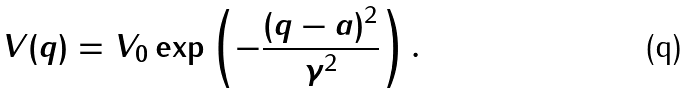Convert formula to latex. <formula><loc_0><loc_0><loc_500><loc_500>V ( q ) = V _ { 0 } \exp \left ( - \frac { ( q - a ) ^ { 2 } } { \gamma ^ { 2 } } \right ) .</formula> 